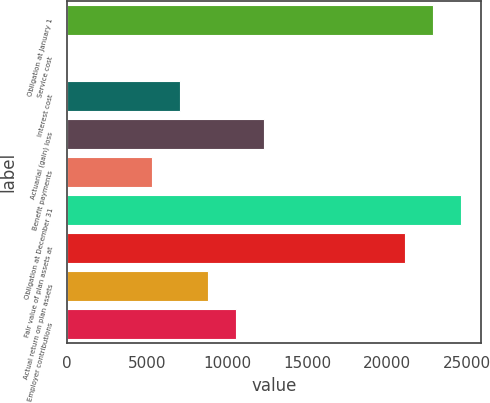<chart> <loc_0><loc_0><loc_500><loc_500><bar_chart><fcel>Obligation at January 1<fcel>Service cost<fcel>Interest cost<fcel>Actuarial (gain) loss<fcel>Benefit payments<fcel>Obligation at December 31<fcel>Fair value of plan assets at<fcel>Actual return on plan assets<fcel>Employer contributions<nl><fcel>22871.3<fcel>3<fcel>7039.4<fcel>12316.7<fcel>5280.3<fcel>24630.4<fcel>21112.2<fcel>8798.5<fcel>10557.6<nl></chart> 